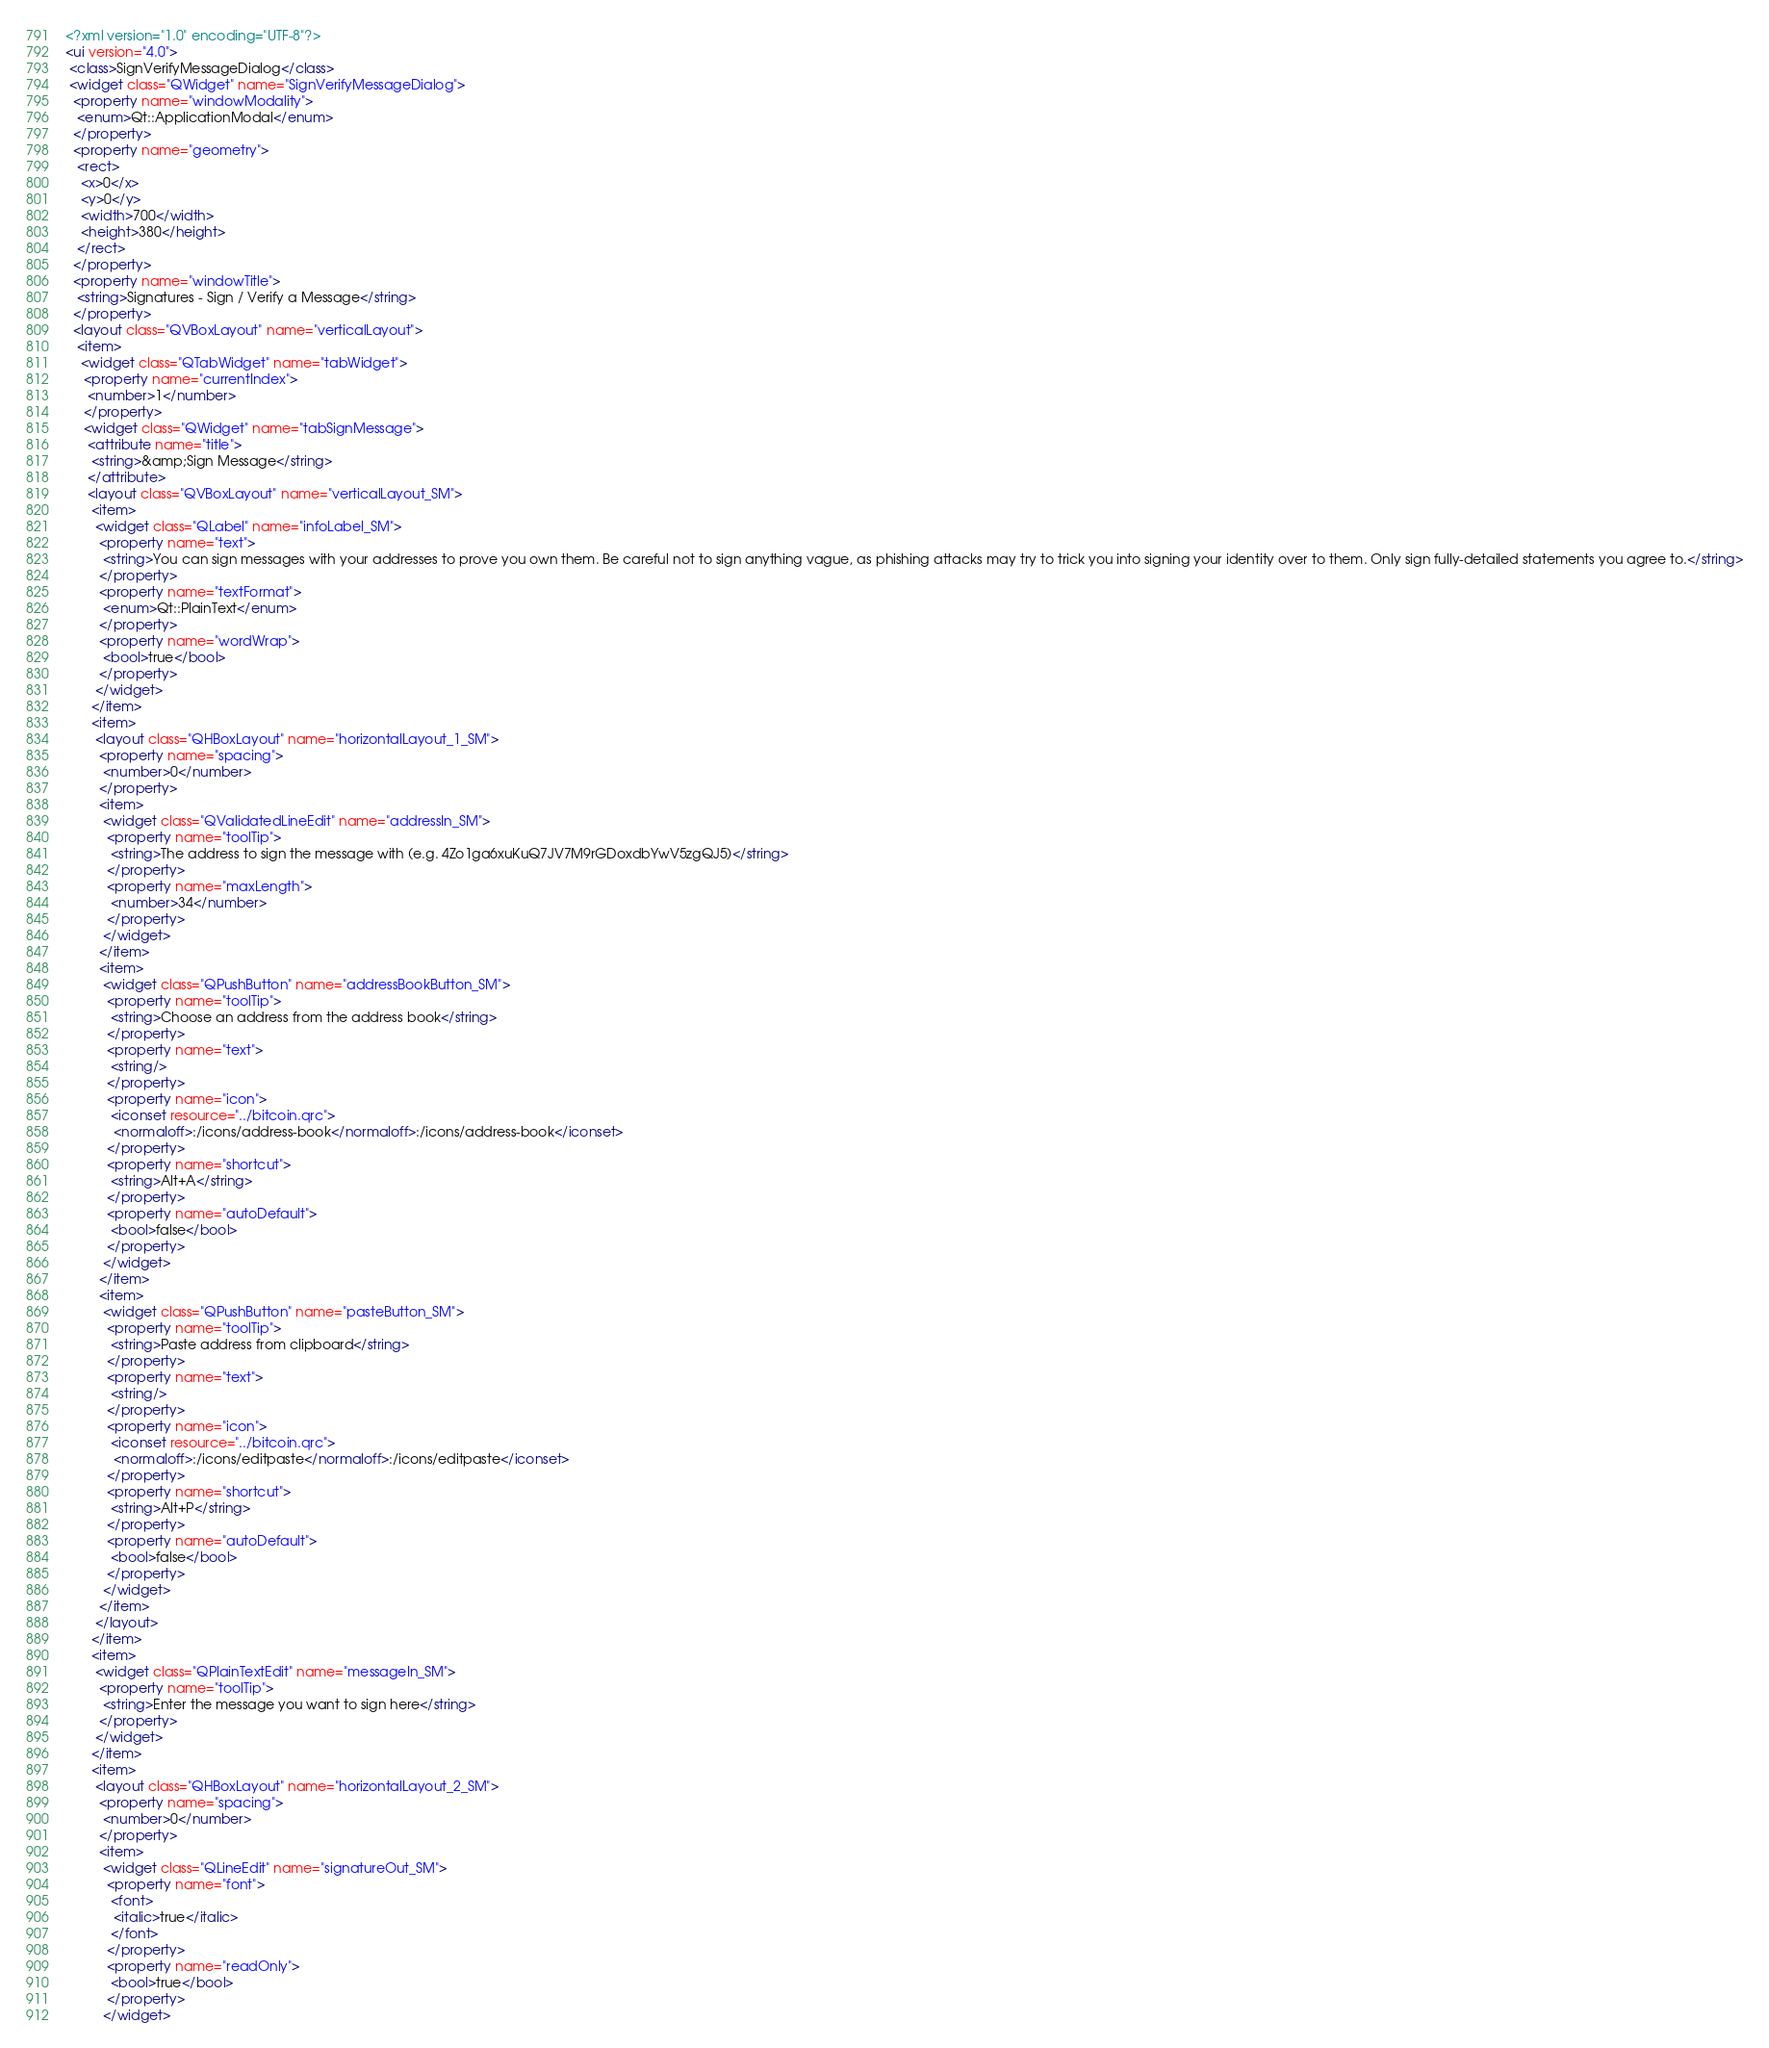<code> <loc_0><loc_0><loc_500><loc_500><_XML_><?xml version="1.0" encoding="UTF-8"?>
<ui version="4.0">
 <class>SignVerifyMessageDialog</class>
 <widget class="QWidget" name="SignVerifyMessageDialog">
  <property name="windowModality">
   <enum>Qt::ApplicationModal</enum>
  </property>
  <property name="geometry">
   <rect>
    <x>0</x>
    <y>0</y>
    <width>700</width>
    <height>380</height>
   </rect>
  </property>
  <property name="windowTitle">
   <string>Signatures - Sign / Verify a Message</string>
  </property>
  <layout class="QVBoxLayout" name="verticalLayout">
   <item>
    <widget class="QTabWidget" name="tabWidget">
     <property name="currentIndex">
      <number>1</number>
     </property>
     <widget class="QWidget" name="tabSignMessage">
      <attribute name="title">
       <string>&amp;Sign Message</string>
      </attribute>
      <layout class="QVBoxLayout" name="verticalLayout_SM">
       <item>
        <widget class="QLabel" name="infoLabel_SM">
         <property name="text">
          <string>You can sign messages with your addresses to prove you own them. Be careful not to sign anything vague, as phishing attacks may try to trick you into signing your identity over to them. Only sign fully-detailed statements you agree to.</string>
         </property>
         <property name="textFormat">
          <enum>Qt::PlainText</enum>
         </property>
         <property name="wordWrap">
          <bool>true</bool>
         </property>
        </widget>
       </item>
       <item>
        <layout class="QHBoxLayout" name="horizontalLayout_1_SM">
         <property name="spacing">
          <number>0</number>
         </property>
         <item>
          <widget class="QValidatedLineEdit" name="addressIn_SM">
           <property name="toolTip">
            <string>The address to sign the message with (e.g. 4Zo1ga6xuKuQ7JV7M9rGDoxdbYwV5zgQJ5)</string>
           </property>
           <property name="maxLength">
            <number>34</number>
           </property>
          </widget>
         </item>
         <item>
          <widget class="QPushButton" name="addressBookButton_SM">
           <property name="toolTip">
            <string>Choose an address from the address book</string>
           </property>
           <property name="text">
            <string/>
           </property>
           <property name="icon">
            <iconset resource="../bitcoin.qrc">
             <normaloff>:/icons/address-book</normaloff>:/icons/address-book</iconset>
           </property>
           <property name="shortcut">
            <string>Alt+A</string>
           </property>
           <property name="autoDefault">
            <bool>false</bool>
           </property>
          </widget>
         </item>
         <item>
          <widget class="QPushButton" name="pasteButton_SM">
           <property name="toolTip">
            <string>Paste address from clipboard</string>
           </property>
           <property name="text">
            <string/>
           </property>
           <property name="icon">
            <iconset resource="../bitcoin.qrc">
             <normaloff>:/icons/editpaste</normaloff>:/icons/editpaste</iconset>
           </property>
           <property name="shortcut">
            <string>Alt+P</string>
           </property>
           <property name="autoDefault">
            <bool>false</bool>
           </property>
          </widget>
         </item>
        </layout>
       </item>
       <item>
        <widget class="QPlainTextEdit" name="messageIn_SM">
         <property name="toolTip">
          <string>Enter the message you want to sign here</string>
         </property>
        </widget>
       </item>
       <item>
        <layout class="QHBoxLayout" name="horizontalLayout_2_SM">
         <property name="spacing">
          <number>0</number>
         </property>
         <item>
          <widget class="QLineEdit" name="signatureOut_SM">
           <property name="font">
            <font>
             <italic>true</italic>
            </font>
           </property>
           <property name="readOnly">
            <bool>true</bool>
           </property>
          </widget></code> 